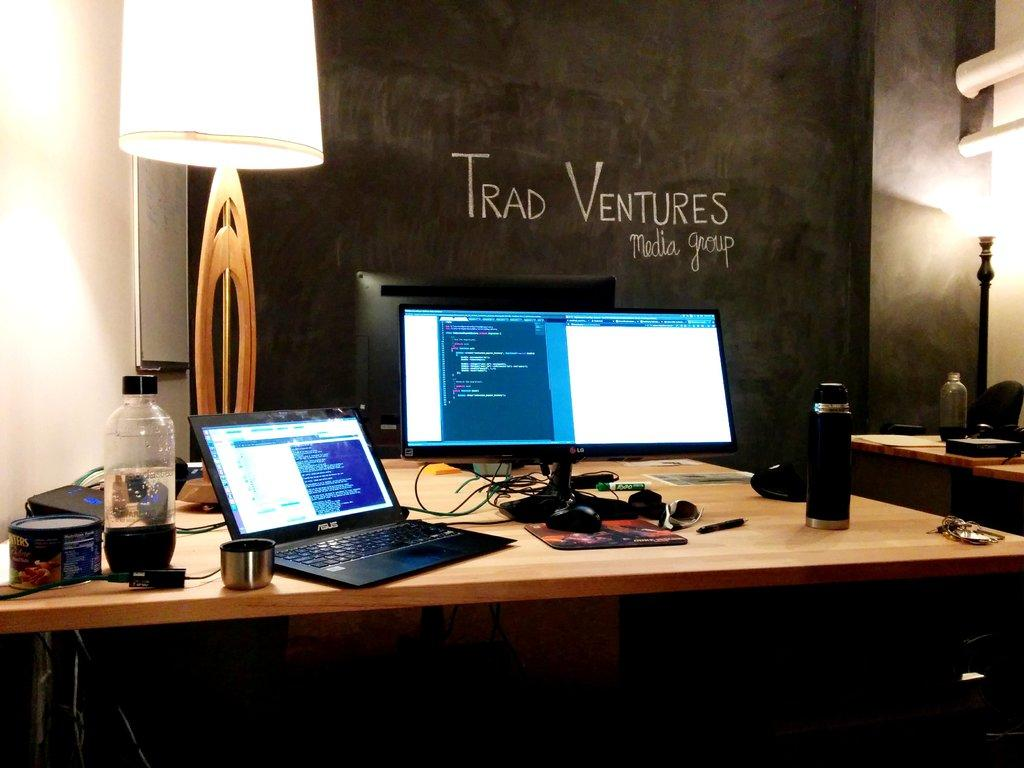What electronic device is visible in the image? There is a laptop in the image. What other electronic device can be seen in the image? There is a system (possibly a computer or monitor) in the image. What non-electronic object is present in the image? There is a bottle in the image. What audio device is visible in the image? There is a soundbar in the image. Where are all these objects located? All these objects are on a table. What can be seen in the background of the image? There is a blackboard and a lamp in the background of the image. What size of pin is being used to hold the blackboard in the image? There is no pin visible in the image, and the blackboard is not being held up by any pin. 